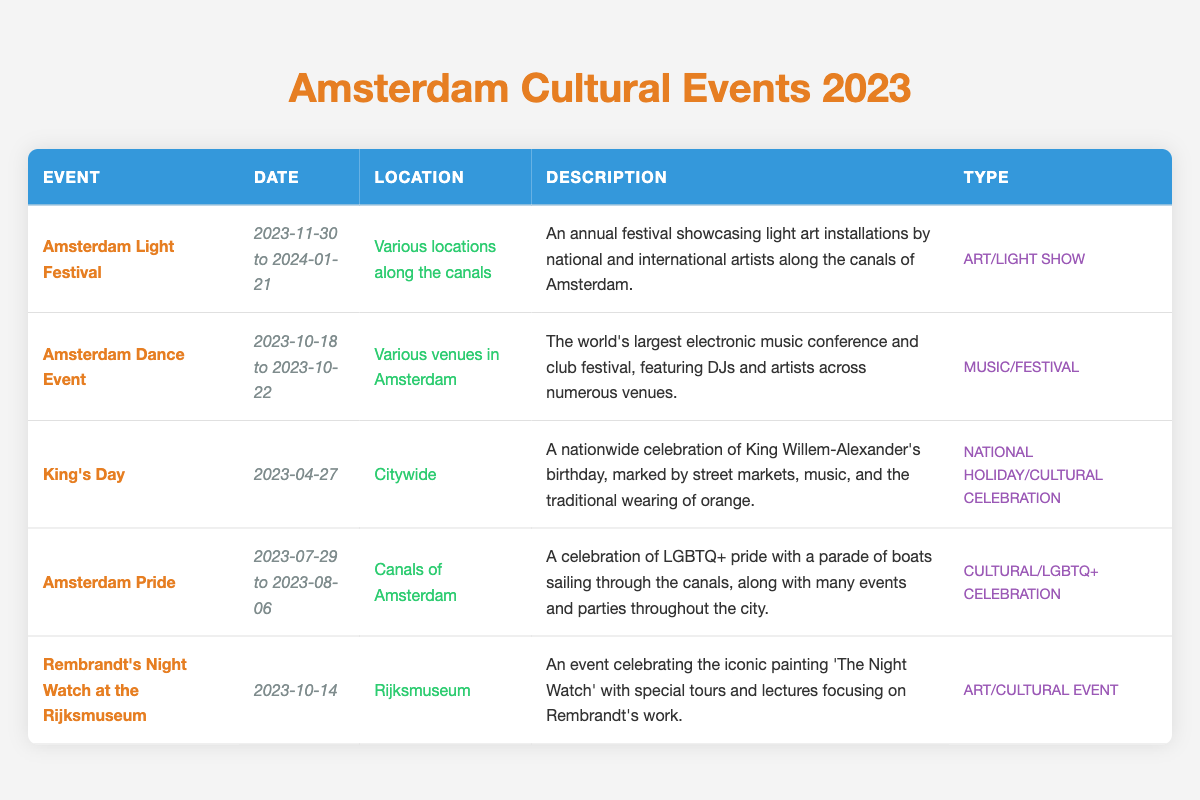What is the date range for the Amsterdam Light Festival in 2023? The date for the Amsterdam Light Festival is listed as "2023-11-30 to 2024-01-21" in the table.
Answer: 2023-11-30 to 2024-01-21 Which event happens first in 2023, Amsterdam Dance Event or Rembrandt's Night Watch at the Rijksmuseum? The Amsterdam Dance Event takes place from "2023-10-18 to 2023-10-22" while Rembrandt's Night Watch event is on "2023-10-14". Since October 14 is earlier than October 18, the Rembrandt event happens first.
Answer: Rembrandt's Night Watch at the Rijksmuseum How many events are listed in total for Amsterdam cultural events in 2023? There are five distinct events listed in the table, as each event is represented by one row. Counting the rows gives a total of 5 events.
Answer: 5 Is Amsterdam Pride celebrated during the summer? The table shows that Amsterdam Pride takes place from "2023-07-29 to 2023-08-06." Since both of these dates fall in the summer months of July and August, the statement is true.
Answer: Yes What type of event is King's Day classified as, and what activities are featured? King's Day is categorized as a "National Holiday/Cultural celebration." The table describes activities such as street markets, music, and the tradition of wearing orange, which are key features of this event.
Answer: National Holiday/Cultural celebration; street markets, music, wearing orange Which event features art installations along the canals? The Amsterdam Light Festival showcases "light art installations" along the canals of Amsterdam as mentioned in the description of that event.
Answer: Amsterdam Light Festival How many of the events are categorized as cultural celebrations? Among the events listed, "King's Day" and "Amsterdam Pride" qualify as cultural celebrations based on their types. This results in a total of 2 cultural celebrations.
Answer: 2 What is the location for the Amsterdam Dance Event? The table specifies that the Amsterdam Dance Event is held at "Various venues in Amsterdam." This clearly indicates the event does not have a single location but spans multiple places in the city.
Answer: Various venues in Amsterdam What unique feature does Amsterdam Pride include in its celebration? The description states that Amsterdam Pride includes a "parade of boats sailing through the canals," which is a distinct aspect of its celebration, along with various events and parties.
Answer: Parade of boats sailing through the canals 